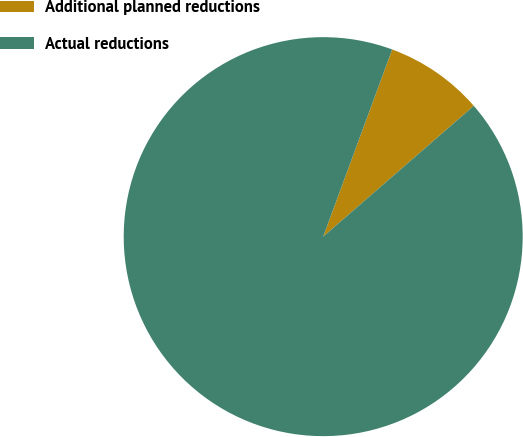<chart> <loc_0><loc_0><loc_500><loc_500><pie_chart><fcel>Additional planned reductions<fcel>Actual reductions<nl><fcel>8.0%<fcel>92.0%<nl></chart> 